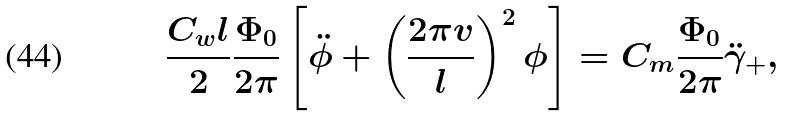<formula> <loc_0><loc_0><loc_500><loc_500>\frac { C _ { w } l } { 2 } \frac { \Phi _ { 0 } } { 2 \pi } \left [ \ddot { \phi } + \left ( \frac { 2 \pi v } { l } \right ) ^ { 2 } \phi \right ] = C _ { m } \frac { \Phi _ { 0 } } { 2 \pi } \ddot { \gamma } _ { + } ,</formula> 